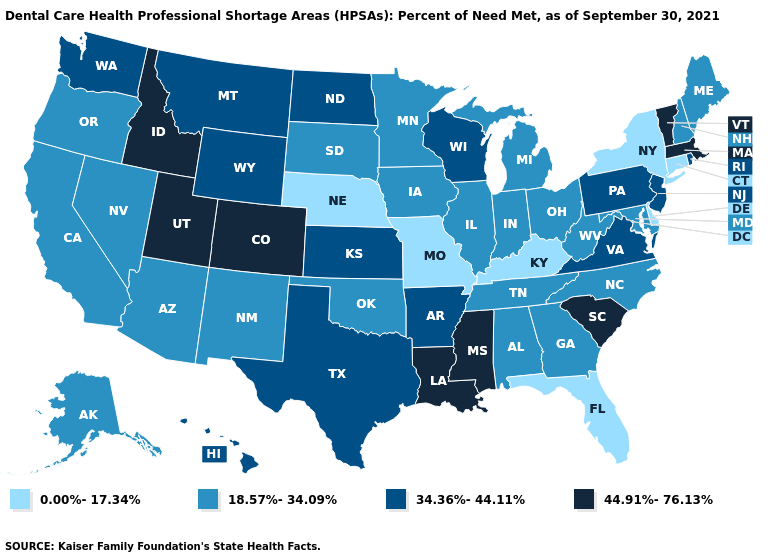Does Colorado have the highest value in the USA?
Write a very short answer. Yes. Name the states that have a value in the range 0.00%-17.34%?
Give a very brief answer. Connecticut, Delaware, Florida, Kentucky, Missouri, Nebraska, New York. Among the states that border Indiana , does Kentucky have the highest value?
Keep it brief. No. What is the lowest value in the West?
Answer briefly. 18.57%-34.09%. Name the states that have a value in the range 34.36%-44.11%?
Concise answer only. Arkansas, Hawaii, Kansas, Montana, New Jersey, North Dakota, Pennsylvania, Rhode Island, Texas, Virginia, Washington, Wisconsin, Wyoming. What is the value of Missouri?
Be succinct. 0.00%-17.34%. What is the value of Utah?
Concise answer only. 44.91%-76.13%. Does Massachusetts have the same value as Idaho?
Give a very brief answer. Yes. Name the states that have a value in the range 44.91%-76.13%?
Be succinct. Colorado, Idaho, Louisiana, Massachusetts, Mississippi, South Carolina, Utah, Vermont. What is the lowest value in states that border Kansas?
Keep it brief. 0.00%-17.34%. Name the states that have a value in the range 0.00%-17.34%?
Give a very brief answer. Connecticut, Delaware, Florida, Kentucky, Missouri, Nebraska, New York. Name the states that have a value in the range 34.36%-44.11%?
Be succinct. Arkansas, Hawaii, Kansas, Montana, New Jersey, North Dakota, Pennsylvania, Rhode Island, Texas, Virginia, Washington, Wisconsin, Wyoming. Name the states that have a value in the range 0.00%-17.34%?
Quick response, please. Connecticut, Delaware, Florida, Kentucky, Missouri, Nebraska, New York. Does the first symbol in the legend represent the smallest category?
Quick response, please. Yes. 